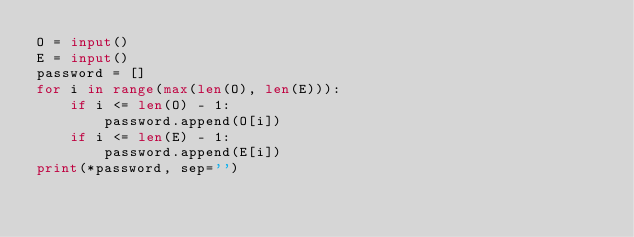<code> <loc_0><loc_0><loc_500><loc_500><_Python_>O = input()
E = input()
password = []
for i in range(max(len(O), len(E))):
    if i <= len(O) - 1:
        password.append(O[i])
    if i <= len(E) - 1:
        password.append(E[i])
print(*password, sep='')</code> 